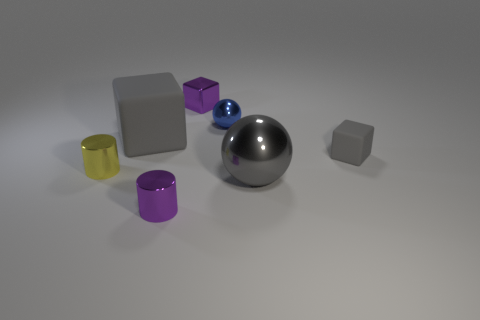What number of big rubber cubes have the same color as the shiny block?
Your answer should be very brief. 0. Are there fewer gray spheres that are behind the big matte object than tiny rubber blocks that are behind the small blue metallic ball?
Your answer should be very brief. No. How many big things are in front of the blue object?
Provide a succinct answer. 2. Is there a tiny cylinder that has the same material as the tiny ball?
Provide a succinct answer. Yes. Are there more yellow things behind the big gray metallic sphere than purple metal cubes behind the metallic block?
Keep it short and to the point. Yes. What size is the blue object?
Your response must be concise. Small. What shape is the large gray thing that is to the right of the purple shiny block?
Provide a succinct answer. Sphere. Do the blue thing and the big shiny thing have the same shape?
Your answer should be compact. Yes. Are there the same number of tiny purple things in front of the yellow cylinder and gray matte objects?
Your answer should be very brief. No. The tiny blue thing is what shape?
Keep it short and to the point. Sphere. 